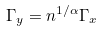Convert formula to latex. <formula><loc_0><loc_0><loc_500><loc_500>\Gamma _ { y } = n ^ { 1 / \alpha } \Gamma _ { x }</formula> 